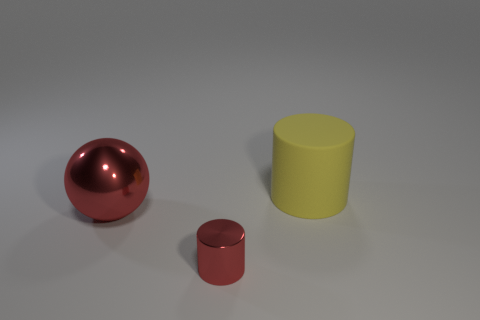What number of things are both in front of the big yellow matte cylinder and on the right side of the large red metal thing?
Give a very brief answer. 1. The thing that is on the left side of the red object that is in front of the metal object behind the small metal object is what shape?
Your response must be concise. Sphere. Is there any other thing that is the same shape as the large red object?
Your answer should be compact. No. What number of blocks are either small objects or big shiny things?
Keep it short and to the point. 0. Is the color of the big thing in front of the large yellow cylinder the same as the small metal cylinder?
Keep it short and to the point. Yes. The red object to the right of the big thing that is on the left side of the cylinder left of the big matte thing is made of what material?
Your answer should be compact. Metal. Does the matte object have the same size as the red sphere?
Your answer should be compact. Yes. Is the color of the large sphere the same as the object that is on the right side of the small red thing?
Make the answer very short. No. There is a thing that is the same material as the large ball; what is its shape?
Your answer should be very brief. Cylinder. Do the object to the left of the red shiny cylinder and the large yellow object have the same shape?
Offer a very short reply. No. 